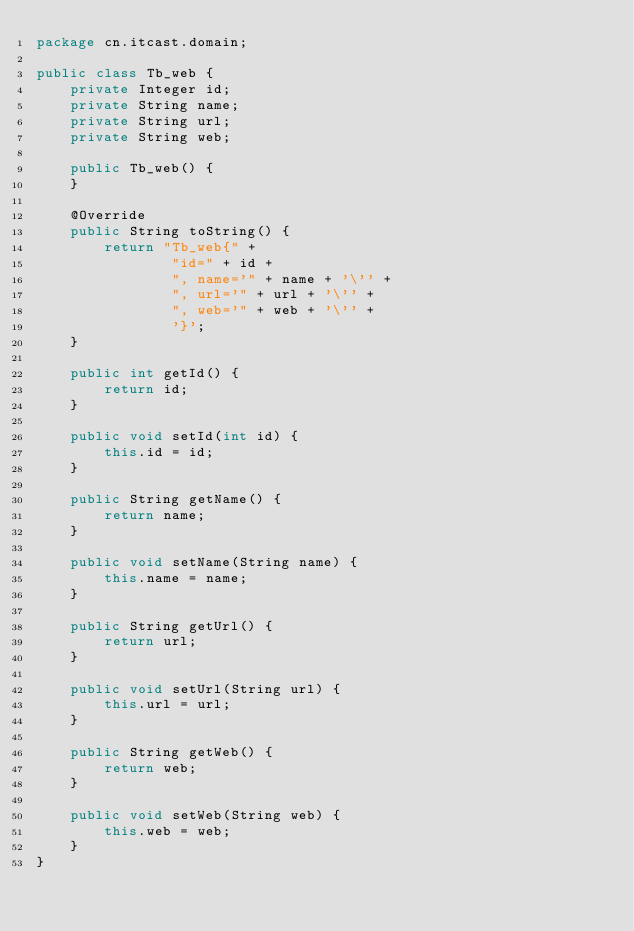Convert code to text. <code><loc_0><loc_0><loc_500><loc_500><_Java_>package cn.itcast.domain;

public class Tb_web {
    private Integer id;
    private String name;
    private String url;
    private String web;

    public Tb_web() {
    }

    @Override
    public String toString() {
        return "Tb_web{" +
                "id=" + id +
                ", name='" + name + '\'' +
                ", url='" + url + '\'' +
                ", web='" + web + '\'' +
                '}';
    }

    public int getId() {
        return id;
    }

    public void setId(int id) {
        this.id = id;
    }

    public String getName() {
        return name;
    }

    public void setName(String name) {
        this.name = name;
    }

    public String getUrl() {
        return url;
    }

    public void setUrl(String url) {
        this.url = url;
    }

    public String getWeb() {
        return web;
    }

    public void setWeb(String web) {
        this.web = web;
    }
}
</code> 